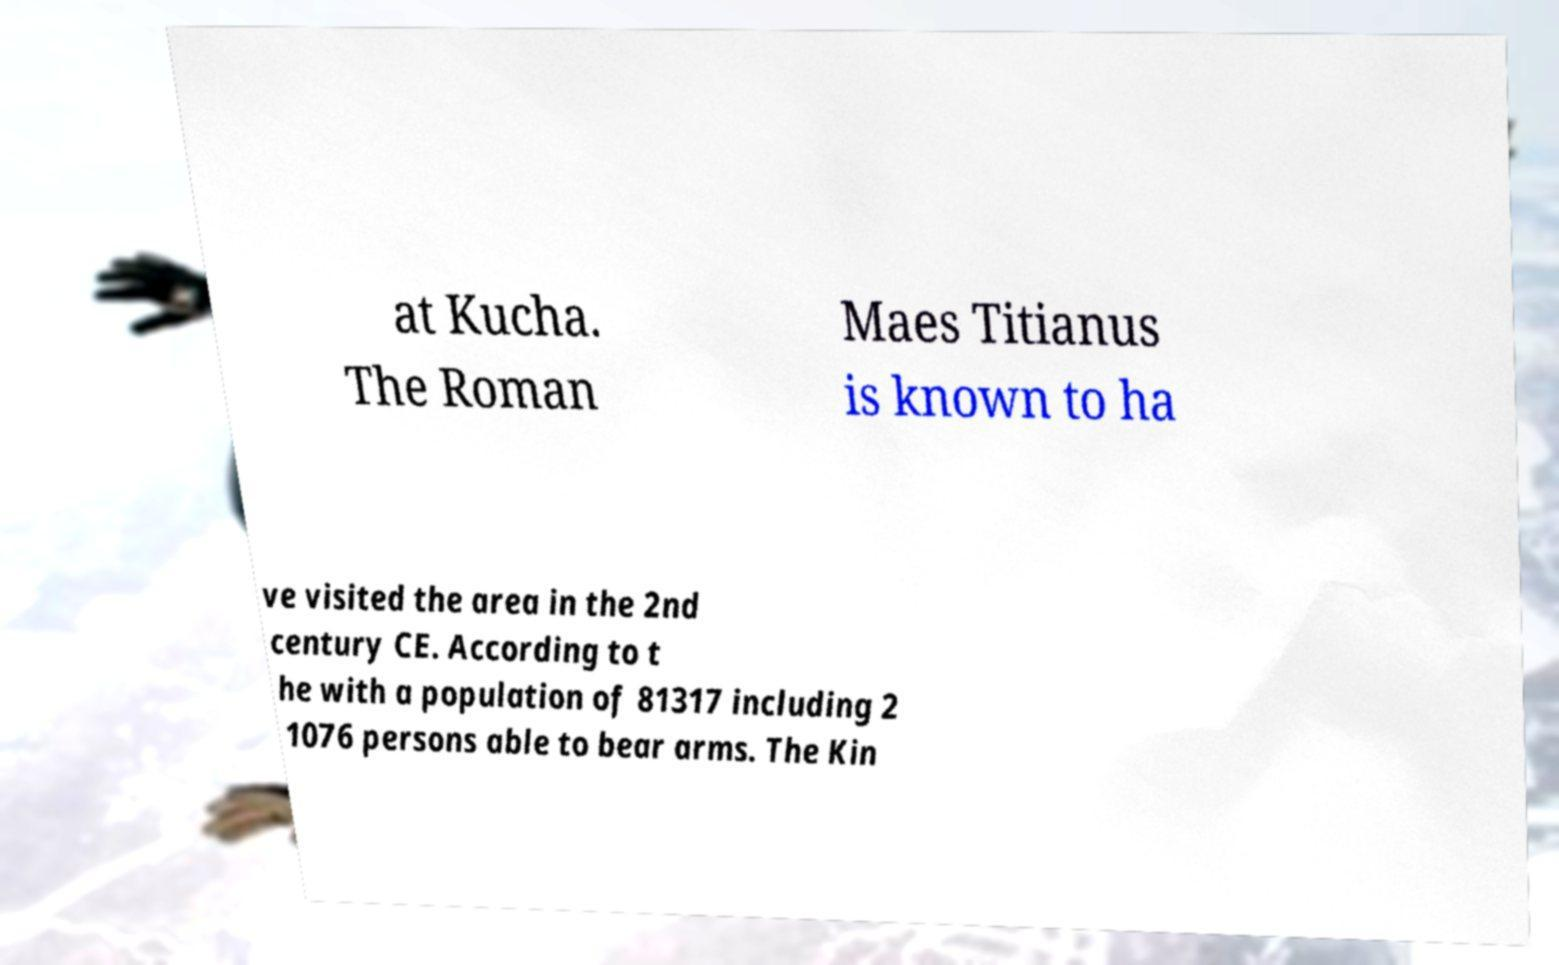Can you read and provide the text displayed in the image?This photo seems to have some interesting text. Can you extract and type it out for me? at Kucha. The Roman Maes Titianus is known to ha ve visited the area in the 2nd century CE. According to t he with a population of 81317 including 2 1076 persons able to bear arms. The Kin 